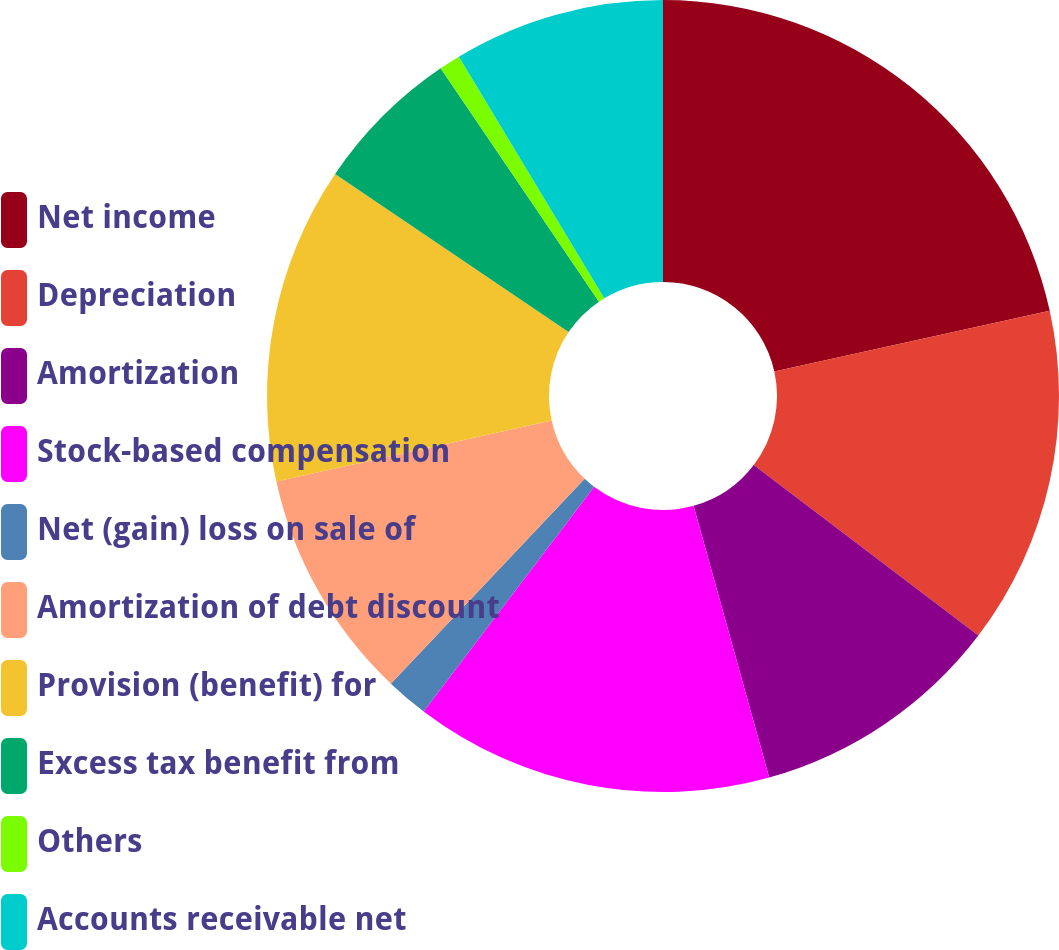<chart> <loc_0><loc_0><loc_500><loc_500><pie_chart><fcel>Net income<fcel>Depreciation<fcel>Amortization<fcel>Stock-based compensation<fcel>Net (gain) loss on sale of<fcel>Amortization of debt discount<fcel>Provision (benefit) for<fcel>Excess tax benefit from<fcel>Others<fcel>Accounts receivable net<nl><fcel>21.55%<fcel>13.79%<fcel>10.34%<fcel>14.65%<fcel>1.73%<fcel>9.48%<fcel>12.93%<fcel>6.04%<fcel>0.87%<fcel>8.62%<nl></chart> 